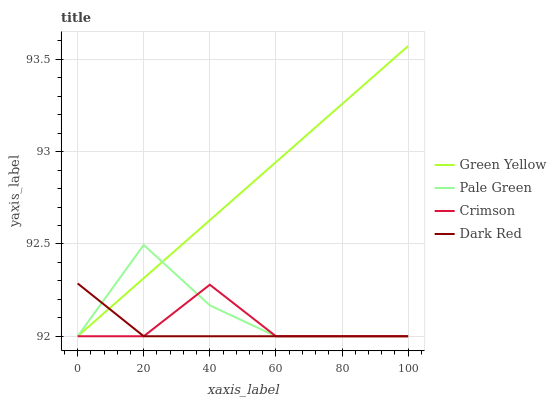Does Pale Green have the minimum area under the curve?
Answer yes or no. No. Does Pale Green have the maximum area under the curve?
Answer yes or no. No. Is Pale Green the smoothest?
Answer yes or no. No. Is Green Yellow the roughest?
Answer yes or no. No. Does Pale Green have the highest value?
Answer yes or no. No. 